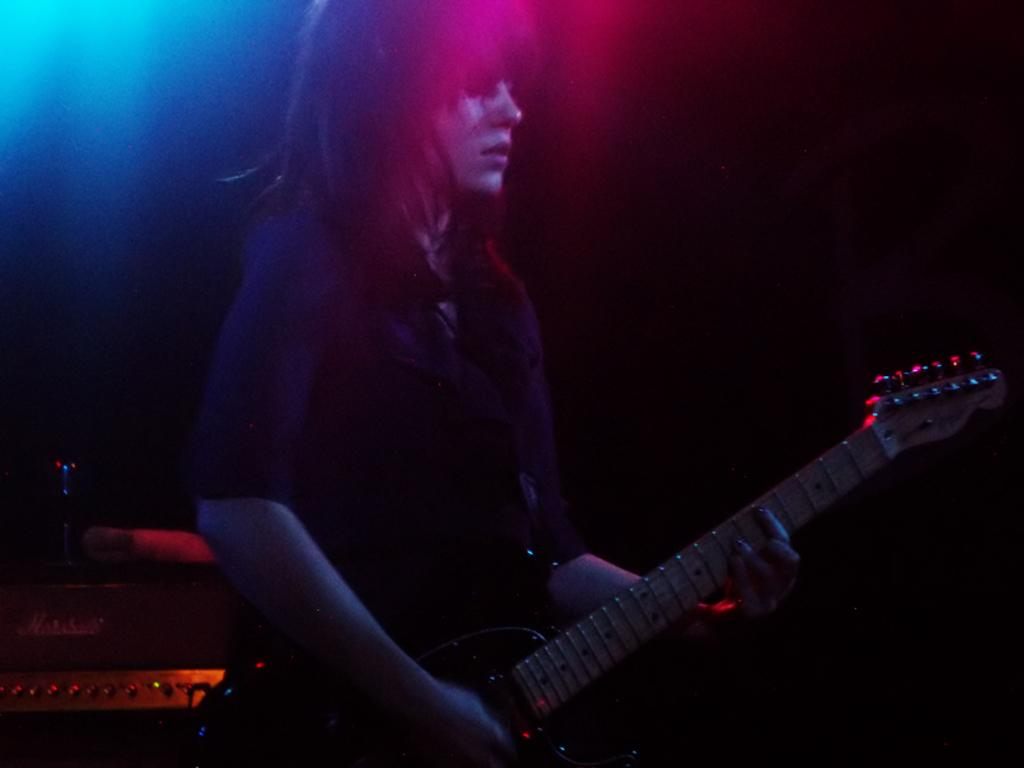Who is the main subject in the image? There is a woman in the image. What is the woman doing in the image? The woman is playing a guitar. What can be seen behind the woman in the image? There is a device behind the woman. What colors are present at the top of the image? The top of the image contains blue and pinkish colors. How many sisters are visible in the image? There are no sisters present in the image; it only features a woman playing a guitar. What type of glove can be seen on the woman's hand in the image? There is no glove present on the woman's hand in the image; she is playing a guitar with her fingers. 